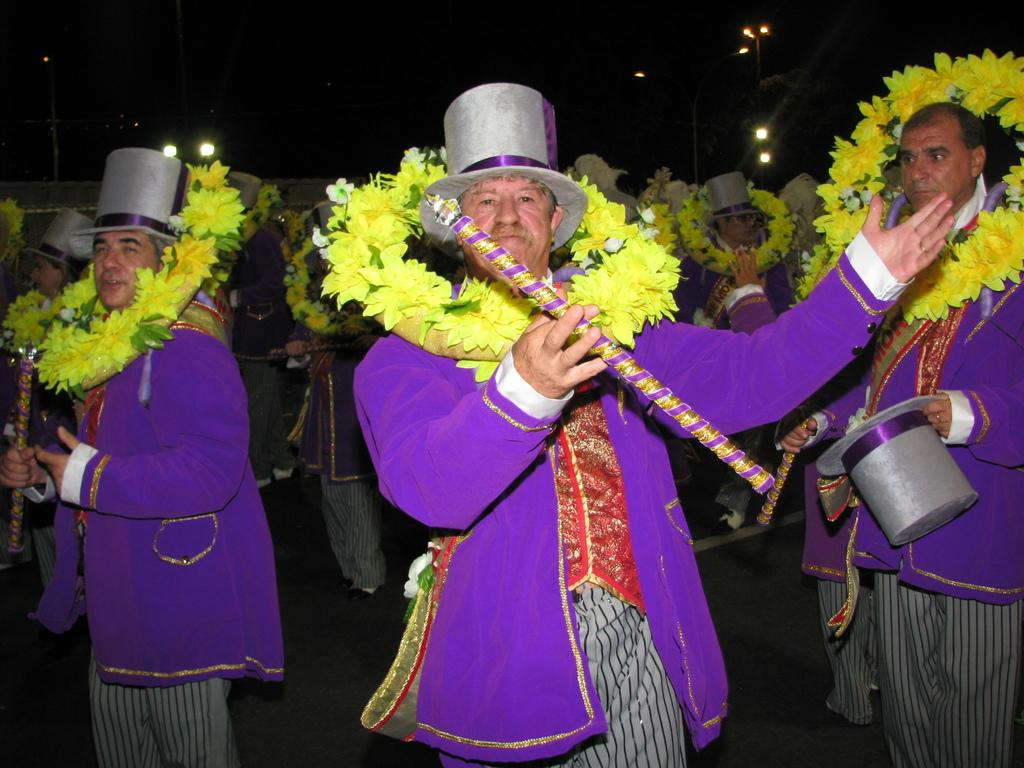What is the common feature among the men in the image? The men in the image are wearing purple jackets. What accessories are the men wearing in the image? The men are wearing garlands and hats in the image. What musical instruments are the men holding in the image? The men are holding flutes in the image. What can be seen in the background of the image? There are lights visible in the background of the image. What type of spark can be seen coming from the cabbage in the image? There is no cabbage present in the image, and therefore no spark can be observed. 